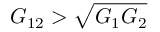Convert formula to latex. <formula><loc_0><loc_0><loc_500><loc_500>G _ { 1 2 } > \sqrt { G _ { 1 } G _ { 2 } }</formula> 